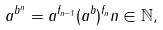Convert formula to latex. <formula><loc_0><loc_0><loc_500><loc_500>a ^ { b ^ { n } } = a ^ { f _ { n - 1 } } ( a ^ { b } ) ^ { f _ { n } } n \in \mathbb { N } ,</formula> 